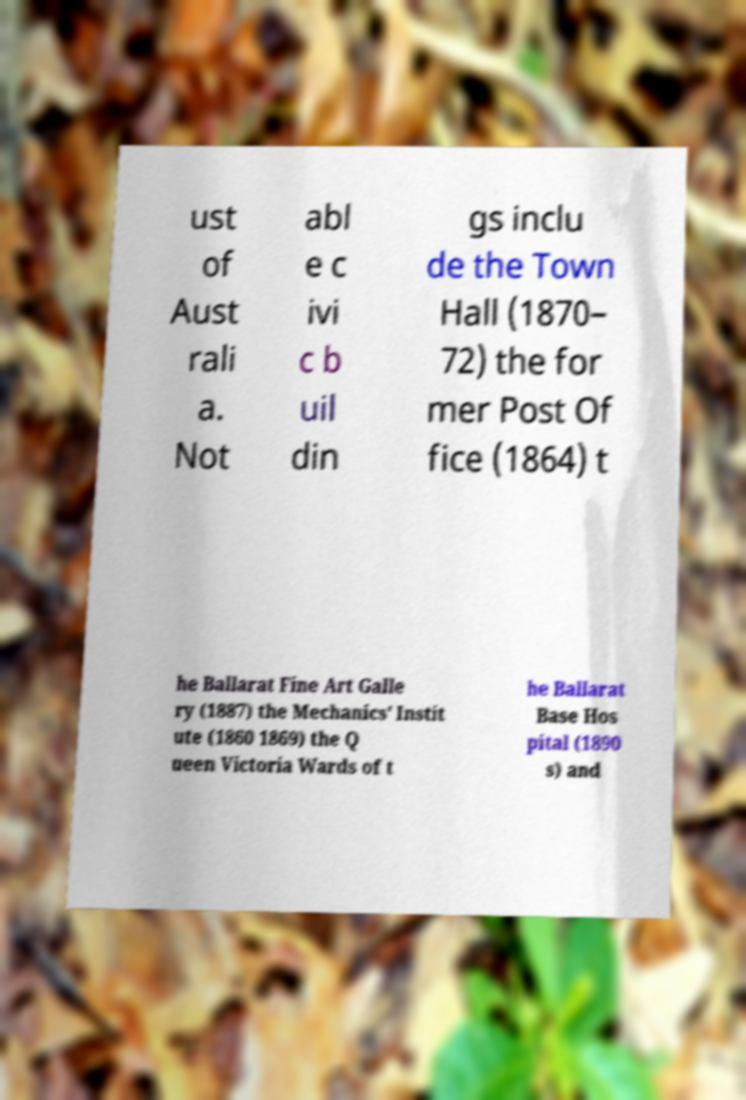There's text embedded in this image that I need extracted. Can you transcribe it verbatim? ust of Aust rali a. Not abl e c ivi c b uil din gs inclu de the Town Hall (1870– 72) the for mer Post Of fice (1864) t he Ballarat Fine Art Galle ry (1887) the Mechanics' Instit ute (1860 1869) the Q ueen Victoria Wards of t he Ballarat Base Hos pital (1890 s) and 